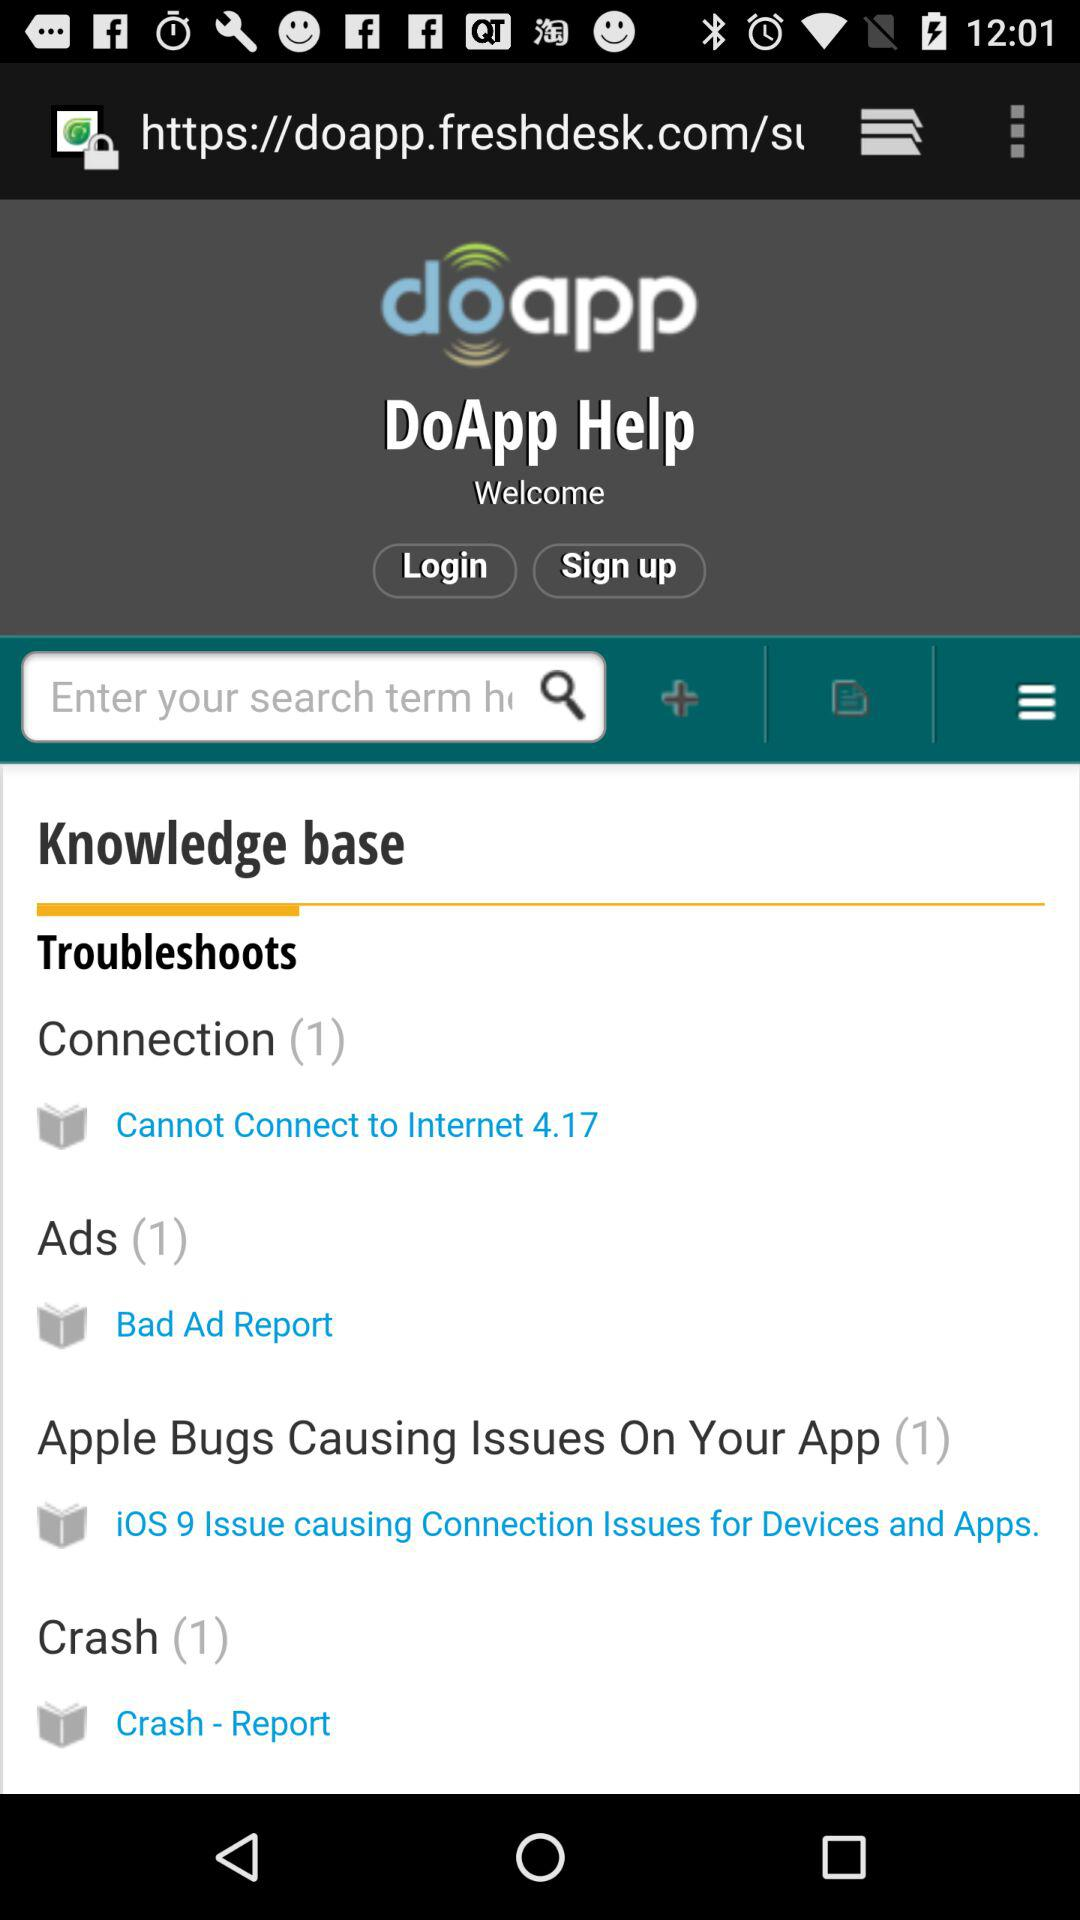To what connection can we not connect? You can not connect to Internet 4.17. 